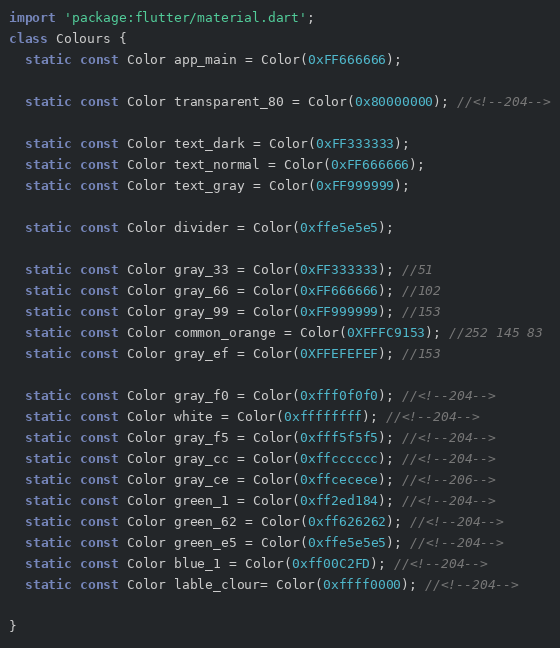<code> <loc_0><loc_0><loc_500><loc_500><_Dart_>import 'package:flutter/material.dart';
class Colours {
  static const Color app_main = Color(0xFF666666);

  static const Color transparent_80 = Color(0x80000000); //<!--204-->

  static const Color text_dark = Color(0xFF333333);
  static const Color text_normal = Color(0xFF666666);
  static const Color text_gray = Color(0xFF999999);

  static const Color divider = Color(0xffe5e5e5);

  static const Color gray_33 = Color(0xFF333333); //51
  static const Color gray_66 = Color(0xFF666666); //102
  static const Color gray_99 = Color(0xFF999999); //153
  static const Color common_orange = Color(0XFFFC9153); //252 145 83
  static const Color gray_ef = Color(0XFFEFEFEF); //153

  static const Color gray_f0 = Color(0xfff0f0f0); //<!--204-->
  static const Color white = Color(0xffffffff); //<!--204-->
  static const Color gray_f5 = Color(0xfff5f5f5); //<!--204-->
  static const Color gray_cc = Color(0xffcccccc); //<!--204-->
  static const Color gray_ce = Color(0xffcecece); //<!--206-->
  static const Color green_1 = Color(0xff2ed184); //<!--204-->
  static const Color green_62 = Color(0xff626262); //<!--204-->
  static const Color green_e5 = Color(0xffe5e5e5); //<!--204-->
  static const Color blue_1 = Color(0xff00C2FD); //<!--204-->
  static const Color lable_clour= Color(0xffff0000); //<!--204-->

}</code> 